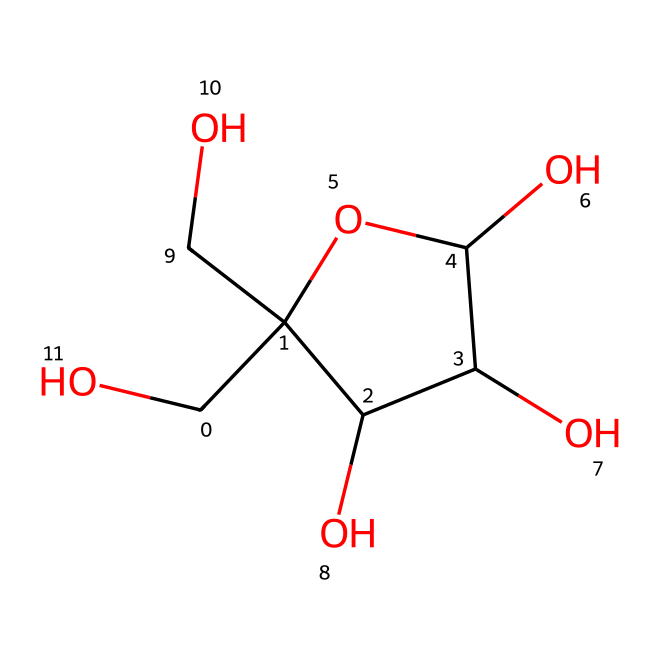What type of compound is represented by this SMILES? The SMILES structure contains several hydroxyl (–OH) groups and a ring structure, indicating it is a sugar alcohol or carbohydrate, likely a form of sugar like glucose or fructose.
Answer: carbohydrate How many oxygen atoms are present in this chemical? By examining the SMILES, we can count the oxygen atoms present in the structure. There are four oxygen atoms linked to hydroxyl groups.
Answer: 4 What is the basic structure of this compound? The compound has a cyclic structure with connected carbon and oxygen atoms, indicating a ring structure that is characteristic of some sugars, particularly cyclic forms.
Answer: cyclic Does this compound have any functional groups? Yes, the presence of –OH groups represents hydroxyl functional groups, which are typical in alcohols and carbohydrates, contributing to the compound's properties.
Answer: hydroxyl What is the primary use of this type of compound in soft drinks? Compounds like this are primarily used as sweeteners in soft drinks due to their sugary taste and ability to enhance flavor.
Answer: sweetener How many carbon atoms are in this chemical structure? Counting the carbon atoms represented in the SMILES shows there are six carbon atoms in the structure, forming the backbone of the compound.
Answer: 6 